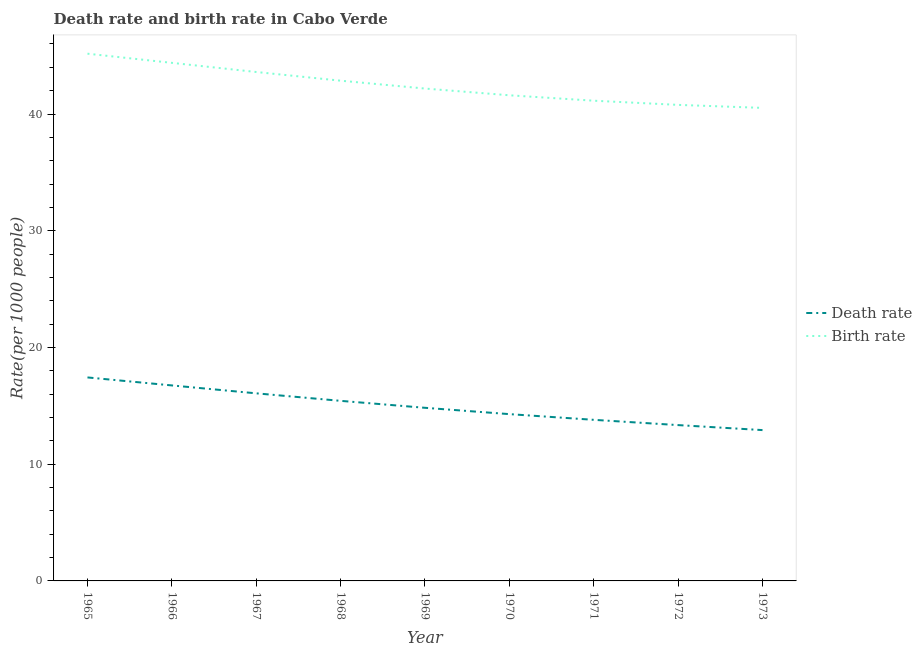How many different coloured lines are there?
Ensure brevity in your answer.  2. Does the line corresponding to birth rate intersect with the line corresponding to death rate?
Offer a very short reply. No. What is the death rate in 1967?
Ensure brevity in your answer.  16.07. Across all years, what is the maximum birth rate?
Your answer should be compact. 45.17. Across all years, what is the minimum birth rate?
Keep it short and to the point. 40.52. In which year was the death rate maximum?
Offer a very short reply. 1965. In which year was the birth rate minimum?
Your answer should be compact. 1973. What is the total birth rate in the graph?
Your answer should be compact. 382.24. What is the difference between the birth rate in 1969 and that in 1971?
Make the answer very short. 1.04. What is the difference between the birth rate in 1967 and the death rate in 1968?
Give a very brief answer. 28.17. What is the average death rate per year?
Your answer should be very brief. 14.99. In the year 1973, what is the difference between the birth rate and death rate?
Your answer should be compact. 27.6. In how many years, is the birth rate greater than 32?
Keep it short and to the point. 9. What is the ratio of the death rate in 1968 to that in 1972?
Make the answer very short. 1.16. Is the birth rate in 1971 less than that in 1972?
Give a very brief answer. No. What is the difference between the highest and the second highest death rate?
Keep it short and to the point. 0.68. What is the difference between the highest and the lowest birth rate?
Your answer should be compact. 4.64. In how many years, is the birth rate greater than the average birth rate taken over all years?
Offer a terse response. 4. Does the death rate monotonically increase over the years?
Provide a short and direct response. No. How many lines are there?
Offer a terse response. 2. Does the graph contain grids?
Provide a short and direct response. No. Where does the legend appear in the graph?
Provide a short and direct response. Center right. How many legend labels are there?
Offer a terse response. 2. How are the legend labels stacked?
Provide a short and direct response. Vertical. What is the title of the graph?
Ensure brevity in your answer.  Death rate and birth rate in Cabo Verde. What is the label or title of the Y-axis?
Your answer should be compact. Rate(per 1000 people). What is the Rate(per 1000 people) in Death rate in 1965?
Keep it short and to the point. 17.43. What is the Rate(per 1000 people) of Birth rate in 1965?
Offer a terse response. 45.17. What is the Rate(per 1000 people) in Death rate in 1966?
Keep it short and to the point. 16.75. What is the Rate(per 1000 people) of Birth rate in 1966?
Give a very brief answer. 44.38. What is the Rate(per 1000 people) in Death rate in 1967?
Ensure brevity in your answer.  16.07. What is the Rate(per 1000 people) in Birth rate in 1967?
Your answer should be very brief. 43.6. What is the Rate(per 1000 people) in Death rate in 1968?
Offer a very short reply. 15.43. What is the Rate(per 1000 people) of Birth rate in 1968?
Your answer should be very brief. 42.85. What is the Rate(per 1000 people) of Death rate in 1969?
Ensure brevity in your answer.  14.83. What is the Rate(per 1000 people) of Birth rate in 1969?
Make the answer very short. 42.18. What is the Rate(per 1000 people) of Death rate in 1970?
Your response must be concise. 14.29. What is the Rate(per 1000 people) of Birth rate in 1970?
Provide a short and direct response. 41.6. What is the Rate(per 1000 people) of Death rate in 1971?
Your answer should be compact. 13.8. What is the Rate(per 1000 people) in Birth rate in 1971?
Keep it short and to the point. 41.14. What is the Rate(per 1000 people) in Death rate in 1972?
Give a very brief answer. 13.35. What is the Rate(per 1000 people) in Birth rate in 1972?
Make the answer very short. 40.78. What is the Rate(per 1000 people) in Death rate in 1973?
Provide a succinct answer. 12.92. What is the Rate(per 1000 people) of Birth rate in 1973?
Offer a terse response. 40.52. Across all years, what is the maximum Rate(per 1000 people) in Death rate?
Your response must be concise. 17.43. Across all years, what is the maximum Rate(per 1000 people) of Birth rate?
Give a very brief answer. 45.17. Across all years, what is the minimum Rate(per 1000 people) in Death rate?
Provide a succinct answer. 12.92. Across all years, what is the minimum Rate(per 1000 people) in Birth rate?
Offer a terse response. 40.52. What is the total Rate(per 1000 people) in Death rate in the graph?
Give a very brief answer. 134.87. What is the total Rate(per 1000 people) of Birth rate in the graph?
Your response must be concise. 382.24. What is the difference between the Rate(per 1000 people) of Death rate in 1965 and that in 1966?
Offer a very short reply. 0.69. What is the difference between the Rate(per 1000 people) in Birth rate in 1965 and that in 1966?
Make the answer very short. 0.78. What is the difference between the Rate(per 1000 people) in Death rate in 1965 and that in 1967?
Make the answer very short. 1.36. What is the difference between the Rate(per 1000 people) in Birth rate in 1965 and that in 1967?
Give a very brief answer. 1.57. What is the difference between the Rate(per 1000 people) in Death rate in 1965 and that in 1968?
Your answer should be compact. 2.01. What is the difference between the Rate(per 1000 people) in Birth rate in 1965 and that in 1968?
Make the answer very short. 2.31. What is the difference between the Rate(per 1000 people) in Death rate in 1965 and that in 1969?
Your answer should be compact. 2.6. What is the difference between the Rate(per 1000 people) of Birth rate in 1965 and that in 1969?
Your response must be concise. 2.99. What is the difference between the Rate(per 1000 people) in Death rate in 1965 and that in 1970?
Provide a short and direct response. 3.14. What is the difference between the Rate(per 1000 people) of Birth rate in 1965 and that in 1970?
Ensure brevity in your answer.  3.56. What is the difference between the Rate(per 1000 people) in Death rate in 1965 and that in 1971?
Offer a terse response. 3.63. What is the difference between the Rate(per 1000 people) in Birth rate in 1965 and that in 1971?
Offer a terse response. 4.03. What is the difference between the Rate(per 1000 people) of Death rate in 1965 and that in 1972?
Your response must be concise. 4.08. What is the difference between the Rate(per 1000 people) of Birth rate in 1965 and that in 1972?
Provide a succinct answer. 4.38. What is the difference between the Rate(per 1000 people) in Death rate in 1965 and that in 1973?
Keep it short and to the point. 4.51. What is the difference between the Rate(per 1000 people) of Birth rate in 1965 and that in 1973?
Your response must be concise. 4.64. What is the difference between the Rate(per 1000 people) in Death rate in 1966 and that in 1967?
Keep it short and to the point. 0.68. What is the difference between the Rate(per 1000 people) of Birth rate in 1966 and that in 1967?
Provide a short and direct response. 0.78. What is the difference between the Rate(per 1000 people) in Death rate in 1966 and that in 1968?
Your answer should be compact. 1.32. What is the difference between the Rate(per 1000 people) in Birth rate in 1966 and that in 1968?
Give a very brief answer. 1.53. What is the difference between the Rate(per 1000 people) of Death rate in 1966 and that in 1969?
Give a very brief answer. 1.92. What is the difference between the Rate(per 1000 people) of Birth rate in 1966 and that in 1969?
Ensure brevity in your answer.  2.2. What is the difference between the Rate(per 1000 people) of Death rate in 1966 and that in 1970?
Ensure brevity in your answer.  2.46. What is the difference between the Rate(per 1000 people) in Birth rate in 1966 and that in 1970?
Your answer should be very brief. 2.78. What is the difference between the Rate(per 1000 people) in Death rate in 1966 and that in 1971?
Offer a terse response. 2.95. What is the difference between the Rate(per 1000 people) in Birth rate in 1966 and that in 1971?
Your response must be concise. 3.24. What is the difference between the Rate(per 1000 people) in Death rate in 1966 and that in 1972?
Ensure brevity in your answer.  3.4. What is the difference between the Rate(per 1000 people) in Birth rate in 1966 and that in 1972?
Give a very brief answer. 3.6. What is the difference between the Rate(per 1000 people) in Death rate in 1966 and that in 1973?
Offer a very short reply. 3.83. What is the difference between the Rate(per 1000 people) of Birth rate in 1966 and that in 1973?
Ensure brevity in your answer.  3.86. What is the difference between the Rate(per 1000 people) in Death rate in 1967 and that in 1968?
Offer a terse response. 0.64. What is the difference between the Rate(per 1000 people) in Birth rate in 1967 and that in 1968?
Give a very brief answer. 0.74. What is the difference between the Rate(per 1000 people) in Death rate in 1967 and that in 1969?
Offer a very short reply. 1.24. What is the difference between the Rate(per 1000 people) of Birth rate in 1967 and that in 1969?
Give a very brief answer. 1.42. What is the difference between the Rate(per 1000 people) in Death rate in 1967 and that in 1970?
Your response must be concise. 1.78. What is the difference between the Rate(per 1000 people) in Birth rate in 1967 and that in 1970?
Offer a very short reply. 2. What is the difference between the Rate(per 1000 people) of Death rate in 1967 and that in 1971?
Provide a short and direct response. 2.27. What is the difference between the Rate(per 1000 people) in Birth rate in 1967 and that in 1971?
Ensure brevity in your answer.  2.46. What is the difference between the Rate(per 1000 people) of Death rate in 1967 and that in 1972?
Ensure brevity in your answer.  2.72. What is the difference between the Rate(per 1000 people) in Birth rate in 1967 and that in 1972?
Keep it short and to the point. 2.82. What is the difference between the Rate(per 1000 people) in Death rate in 1967 and that in 1973?
Make the answer very short. 3.15. What is the difference between the Rate(per 1000 people) in Birth rate in 1967 and that in 1973?
Provide a short and direct response. 3.08. What is the difference between the Rate(per 1000 people) of Death rate in 1968 and that in 1969?
Provide a short and direct response. 0.6. What is the difference between the Rate(per 1000 people) of Birth rate in 1968 and that in 1969?
Make the answer very short. 0.67. What is the difference between the Rate(per 1000 people) in Death rate in 1968 and that in 1970?
Your answer should be compact. 1.14. What is the difference between the Rate(per 1000 people) in Birth rate in 1968 and that in 1970?
Provide a succinct answer. 1.25. What is the difference between the Rate(per 1000 people) in Death rate in 1968 and that in 1971?
Provide a succinct answer. 1.63. What is the difference between the Rate(per 1000 people) of Birth rate in 1968 and that in 1971?
Offer a very short reply. 1.72. What is the difference between the Rate(per 1000 people) of Death rate in 1968 and that in 1972?
Provide a short and direct response. 2.08. What is the difference between the Rate(per 1000 people) in Birth rate in 1968 and that in 1972?
Your response must be concise. 2.07. What is the difference between the Rate(per 1000 people) in Death rate in 1968 and that in 1973?
Give a very brief answer. 2.51. What is the difference between the Rate(per 1000 people) of Birth rate in 1968 and that in 1973?
Your answer should be very brief. 2.33. What is the difference between the Rate(per 1000 people) of Death rate in 1969 and that in 1970?
Give a very brief answer. 0.54. What is the difference between the Rate(per 1000 people) of Birth rate in 1969 and that in 1970?
Provide a short and direct response. 0.58. What is the difference between the Rate(per 1000 people) in Birth rate in 1969 and that in 1971?
Ensure brevity in your answer.  1.04. What is the difference between the Rate(per 1000 people) in Death rate in 1969 and that in 1972?
Your answer should be very brief. 1.48. What is the difference between the Rate(per 1000 people) in Birth rate in 1969 and that in 1972?
Give a very brief answer. 1.4. What is the difference between the Rate(per 1000 people) in Death rate in 1969 and that in 1973?
Provide a short and direct response. 1.91. What is the difference between the Rate(per 1000 people) of Birth rate in 1969 and that in 1973?
Provide a short and direct response. 1.66. What is the difference between the Rate(per 1000 people) in Death rate in 1970 and that in 1971?
Make the answer very short. 0.49. What is the difference between the Rate(per 1000 people) of Birth rate in 1970 and that in 1971?
Provide a succinct answer. 0.46. What is the difference between the Rate(per 1000 people) in Birth rate in 1970 and that in 1972?
Ensure brevity in your answer.  0.82. What is the difference between the Rate(per 1000 people) of Death rate in 1970 and that in 1973?
Offer a very short reply. 1.37. What is the difference between the Rate(per 1000 people) of Death rate in 1971 and that in 1972?
Give a very brief answer. 0.45. What is the difference between the Rate(per 1000 people) in Birth rate in 1971 and that in 1972?
Keep it short and to the point. 0.36. What is the difference between the Rate(per 1000 people) of Birth rate in 1971 and that in 1973?
Your response must be concise. 0.62. What is the difference between the Rate(per 1000 people) of Death rate in 1972 and that in 1973?
Offer a very short reply. 0.43. What is the difference between the Rate(per 1000 people) of Birth rate in 1972 and that in 1973?
Your answer should be compact. 0.26. What is the difference between the Rate(per 1000 people) of Death rate in 1965 and the Rate(per 1000 people) of Birth rate in 1966?
Offer a terse response. -26.95. What is the difference between the Rate(per 1000 people) of Death rate in 1965 and the Rate(per 1000 people) of Birth rate in 1967?
Offer a very short reply. -26.17. What is the difference between the Rate(per 1000 people) in Death rate in 1965 and the Rate(per 1000 people) in Birth rate in 1968?
Keep it short and to the point. -25.42. What is the difference between the Rate(per 1000 people) of Death rate in 1965 and the Rate(per 1000 people) of Birth rate in 1969?
Give a very brief answer. -24.75. What is the difference between the Rate(per 1000 people) in Death rate in 1965 and the Rate(per 1000 people) in Birth rate in 1970?
Offer a very short reply. -24.17. What is the difference between the Rate(per 1000 people) of Death rate in 1965 and the Rate(per 1000 people) of Birth rate in 1971?
Make the answer very short. -23.71. What is the difference between the Rate(per 1000 people) of Death rate in 1965 and the Rate(per 1000 people) of Birth rate in 1972?
Offer a terse response. -23.35. What is the difference between the Rate(per 1000 people) in Death rate in 1965 and the Rate(per 1000 people) in Birth rate in 1973?
Your answer should be very brief. -23.09. What is the difference between the Rate(per 1000 people) in Death rate in 1966 and the Rate(per 1000 people) in Birth rate in 1967?
Keep it short and to the point. -26.85. What is the difference between the Rate(per 1000 people) of Death rate in 1966 and the Rate(per 1000 people) of Birth rate in 1968?
Ensure brevity in your answer.  -26.11. What is the difference between the Rate(per 1000 people) in Death rate in 1966 and the Rate(per 1000 people) in Birth rate in 1969?
Ensure brevity in your answer.  -25.43. What is the difference between the Rate(per 1000 people) in Death rate in 1966 and the Rate(per 1000 people) in Birth rate in 1970?
Make the answer very short. -24.86. What is the difference between the Rate(per 1000 people) of Death rate in 1966 and the Rate(per 1000 people) of Birth rate in 1971?
Keep it short and to the point. -24.39. What is the difference between the Rate(per 1000 people) in Death rate in 1966 and the Rate(per 1000 people) in Birth rate in 1972?
Your answer should be very brief. -24.03. What is the difference between the Rate(per 1000 people) in Death rate in 1966 and the Rate(per 1000 people) in Birth rate in 1973?
Provide a short and direct response. -23.78. What is the difference between the Rate(per 1000 people) in Death rate in 1967 and the Rate(per 1000 people) in Birth rate in 1968?
Offer a terse response. -26.78. What is the difference between the Rate(per 1000 people) of Death rate in 1967 and the Rate(per 1000 people) of Birth rate in 1969?
Your answer should be compact. -26.11. What is the difference between the Rate(per 1000 people) in Death rate in 1967 and the Rate(per 1000 people) in Birth rate in 1970?
Give a very brief answer. -25.53. What is the difference between the Rate(per 1000 people) of Death rate in 1967 and the Rate(per 1000 people) of Birth rate in 1971?
Offer a very short reply. -25.07. What is the difference between the Rate(per 1000 people) in Death rate in 1967 and the Rate(per 1000 people) in Birth rate in 1972?
Give a very brief answer. -24.71. What is the difference between the Rate(per 1000 people) in Death rate in 1967 and the Rate(per 1000 people) in Birth rate in 1973?
Your response must be concise. -24.45. What is the difference between the Rate(per 1000 people) of Death rate in 1968 and the Rate(per 1000 people) of Birth rate in 1969?
Keep it short and to the point. -26.75. What is the difference between the Rate(per 1000 people) of Death rate in 1968 and the Rate(per 1000 people) of Birth rate in 1970?
Your answer should be very brief. -26.18. What is the difference between the Rate(per 1000 people) of Death rate in 1968 and the Rate(per 1000 people) of Birth rate in 1971?
Keep it short and to the point. -25.71. What is the difference between the Rate(per 1000 people) in Death rate in 1968 and the Rate(per 1000 people) in Birth rate in 1972?
Your response must be concise. -25.36. What is the difference between the Rate(per 1000 people) in Death rate in 1968 and the Rate(per 1000 people) in Birth rate in 1973?
Give a very brief answer. -25.1. What is the difference between the Rate(per 1000 people) of Death rate in 1969 and the Rate(per 1000 people) of Birth rate in 1970?
Keep it short and to the point. -26.77. What is the difference between the Rate(per 1000 people) in Death rate in 1969 and the Rate(per 1000 people) in Birth rate in 1971?
Provide a succinct answer. -26.31. What is the difference between the Rate(per 1000 people) of Death rate in 1969 and the Rate(per 1000 people) of Birth rate in 1972?
Keep it short and to the point. -25.95. What is the difference between the Rate(per 1000 people) of Death rate in 1969 and the Rate(per 1000 people) of Birth rate in 1973?
Your response must be concise. -25.69. What is the difference between the Rate(per 1000 people) in Death rate in 1970 and the Rate(per 1000 people) in Birth rate in 1971?
Make the answer very short. -26.85. What is the difference between the Rate(per 1000 people) in Death rate in 1970 and the Rate(per 1000 people) in Birth rate in 1972?
Your response must be concise. -26.49. What is the difference between the Rate(per 1000 people) in Death rate in 1970 and the Rate(per 1000 people) in Birth rate in 1973?
Give a very brief answer. -26.23. What is the difference between the Rate(per 1000 people) in Death rate in 1971 and the Rate(per 1000 people) in Birth rate in 1972?
Make the answer very short. -26.98. What is the difference between the Rate(per 1000 people) of Death rate in 1971 and the Rate(per 1000 people) of Birth rate in 1973?
Offer a very short reply. -26.72. What is the difference between the Rate(per 1000 people) in Death rate in 1972 and the Rate(per 1000 people) in Birth rate in 1973?
Offer a very short reply. -27.18. What is the average Rate(per 1000 people) of Death rate per year?
Offer a terse response. 14.99. What is the average Rate(per 1000 people) of Birth rate per year?
Your answer should be compact. 42.47. In the year 1965, what is the difference between the Rate(per 1000 people) in Death rate and Rate(per 1000 people) in Birth rate?
Provide a succinct answer. -27.73. In the year 1966, what is the difference between the Rate(per 1000 people) in Death rate and Rate(per 1000 people) in Birth rate?
Your response must be concise. -27.64. In the year 1967, what is the difference between the Rate(per 1000 people) of Death rate and Rate(per 1000 people) of Birth rate?
Your answer should be compact. -27.53. In the year 1968, what is the difference between the Rate(per 1000 people) in Death rate and Rate(per 1000 people) in Birth rate?
Ensure brevity in your answer.  -27.43. In the year 1969, what is the difference between the Rate(per 1000 people) of Death rate and Rate(per 1000 people) of Birth rate?
Make the answer very short. -27.35. In the year 1970, what is the difference between the Rate(per 1000 people) of Death rate and Rate(per 1000 people) of Birth rate?
Provide a short and direct response. -27.32. In the year 1971, what is the difference between the Rate(per 1000 people) of Death rate and Rate(per 1000 people) of Birth rate?
Offer a very short reply. -27.34. In the year 1972, what is the difference between the Rate(per 1000 people) of Death rate and Rate(per 1000 people) of Birth rate?
Ensure brevity in your answer.  -27.43. In the year 1973, what is the difference between the Rate(per 1000 people) in Death rate and Rate(per 1000 people) in Birth rate?
Offer a very short reply. -27.6. What is the ratio of the Rate(per 1000 people) of Death rate in 1965 to that in 1966?
Make the answer very short. 1.04. What is the ratio of the Rate(per 1000 people) in Birth rate in 1965 to that in 1966?
Provide a succinct answer. 1.02. What is the ratio of the Rate(per 1000 people) in Death rate in 1965 to that in 1967?
Provide a succinct answer. 1.08. What is the ratio of the Rate(per 1000 people) of Birth rate in 1965 to that in 1967?
Ensure brevity in your answer.  1.04. What is the ratio of the Rate(per 1000 people) in Death rate in 1965 to that in 1968?
Keep it short and to the point. 1.13. What is the ratio of the Rate(per 1000 people) in Birth rate in 1965 to that in 1968?
Offer a terse response. 1.05. What is the ratio of the Rate(per 1000 people) of Death rate in 1965 to that in 1969?
Provide a short and direct response. 1.18. What is the ratio of the Rate(per 1000 people) in Birth rate in 1965 to that in 1969?
Your answer should be very brief. 1.07. What is the ratio of the Rate(per 1000 people) in Death rate in 1965 to that in 1970?
Provide a succinct answer. 1.22. What is the ratio of the Rate(per 1000 people) in Birth rate in 1965 to that in 1970?
Your answer should be very brief. 1.09. What is the ratio of the Rate(per 1000 people) of Death rate in 1965 to that in 1971?
Your response must be concise. 1.26. What is the ratio of the Rate(per 1000 people) in Birth rate in 1965 to that in 1971?
Offer a very short reply. 1.1. What is the ratio of the Rate(per 1000 people) of Death rate in 1965 to that in 1972?
Your response must be concise. 1.31. What is the ratio of the Rate(per 1000 people) of Birth rate in 1965 to that in 1972?
Provide a short and direct response. 1.11. What is the ratio of the Rate(per 1000 people) in Death rate in 1965 to that in 1973?
Offer a terse response. 1.35. What is the ratio of the Rate(per 1000 people) in Birth rate in 1965 to that in 1973?
Offer a terse response. 1.11. What is the ratio of the Rate(per 1000 people) in Death rate in 1966 to that in 1967?
Offer a terse response. 1.04. What is the ratio of the Rate(per 1000 people) in Birth rate in 1966 to that in 1967?
Ensure brevity in your answer.  1.02. What is the ratio of the Rate(per 1000 people) of Death rate in 1966 to that in 1968?
Provide a succinct answer. 1.09. What is the ratio of the Rate(per 1000 people) in Birth rate in 1966 to that in 1968?
Make the answer very short. 1.04. What is the ratio of the Rate(per 1000 people) of Death rate in 1966 to that in 1969?
Give a very brief answer. 1.13. What is the ratio of the Rate(per 1000 people) in Birth rate in 1966 to that in 1969?
Keep it short and to the point. 1.05. What is the ratio of the Rate(per 1000 people) in Death rate in 1966 to that in 1970?
Offer a very short reply. 1.17. What is the ratio of the Rate(per 1000 people) in Birth rate in 1966 to that in 1970?
Provide a succinct answer. 1.07. What is the ratio of the Rate(per 1000 people) of Death rate in 1966 to that in 1971?
Offer a very short reply. 1.21. What is the ratio of the Rate(per 1000 people) of Birth rate in 1966 to that in 1971?
Your answer should be very brief. 1.08. What is the ratio of the Rate(per 1000 people) of Death rate in 1966 to that in 1972?
Your answer should be very brief. 1.25. What is the ratio of the Rate(per 1000 people) of Birth rate in 1966 to that in 1972?
Your answer should be very brief. 1.09. What is the ratio of the Rate(per 1000 people) in Death rate in 1966 to that in 1973?
Ensure brevity in your answer.  1.3. What is the ratio of the Rate(per 1000 people) in Birth rate in 1966 to that in 1973?
Keep it short and to the point. 1.1. What is the ratio of the Rate(per 1000 people) of Death rate in 1967 to that in 1968?
Your answer should be very brief. 1.04. What is the ratio of the Rate(per 1000 people) in Birth rate in 1967 to that in 1968?
Provide a short and direct response. 1.02. What is the ratio of the Rate(per 1000 people) in Death rate in 1967 to that in 1969?
Your answer should be compact. 1.08. What is the ratio of the Rate(per 1000 people) in Birth rate in 1967 to that in 1969?
Offer a very short reply. 1.03. What is the ratio of the Rate(per 1000 people) in Death rate in 1967 to that in 1970?
Give a very brief answer. 1.12. What is the ratio of the Rate(per 1000 people) of Birth rate in 1967 to that in 1970?
Your answer should be compact. 1.05. What is the ratio of the Rate(per 1000 people) of Death rate in 1967 to that in 1971?
Give a very brief answer. 1.16. What is the ratio of the Rate(per 1000 people) of Birth rate in 1967 to that in 1971?
Offer a very short reply. 1.06. What is the ratio of the Rate(per 1000 people) of Death rate in 1967 to that in 1972?
Provide a succinct answer. 1.2. What is the ratio of the Rate(per 1000 people) of Birth rate in 1967 to that in 1972?
Provide a short and direct response. 1.07. What is the ratio of the Rate(per 1000 people) in Death rate in 1967 to that in 1973?
Provide a short and direct response. 1.24. What is the ratio of the Rate(per 1000 people) of Birth rate in 1967 to that in 1973?
Offer a terse response. 1.08. What is the ratio of the Rate(per 1000 people) in Death rate in 1968 to that in 1969?
Offer a terse response. 1.04. What is the ratio of the Rate(per 1000 people) of Birth rate in 1968 to that in 1969?
Provide a short and direct response. 1.02. What is the ratio of the Rate(per 1000 people) of Death rate in 1968 to that in 1970?
Your answer should be very brief. 1.08. What is the ratio of the Rate(per 1000 people) of Birth rate in 1968 to that in 1970?
Make the answer very short. 1.03. What is the ratio of the Rate(per 1000 people) of Death rate in 1968 to that in 1971?
Make the answer very short. 1.12. What is the ratio of the Rate(per 1000 people) in Birth rate in 1968 to that in 1971?
Offer a terse response. 1.04. What is the ratio of the Rate(per 1000 people) in Death rate in 1968 to that in 1972?
Give a very brief answer. 1.16. What is the ratio of the Rate(per 1000 people) in Birth rate in 1968 to that in 1972?
Ensure brevity in your answer.  1.05. What is the ratio of the Rate(per 1000 people) in Death rate in 1968 to that in 1973?
Give a very brief answer. 1.19. What is the ratio of the Rate(per 1000 people) in Birth rate in 1968 to that in 1973?
Ensure brevity in your answer.  1.06. What is the ratio of the Rate(per 1000 people) of Death rate in 1969 to that in 1970?
Your response must be concise. 1.04. What is the ratio of the Rate(per 1000 people) in Birth rate in 1969 to that in 1970?
Your answer should be very brief. 1.01. What is the ratio of the Rate(per 1000 people) in Death rate in 1969 to that in 1971?
Provide a succinct answer. 1.07. What is the ratio of the Rate(per 1000 people) in Birth rate in 1969 to that in 1971?
Your response must be concise. 1.03. What is the ratio of the Rate(per 1000 people) of Death rate in 1969 to that in 1972?
Your answer should be compact. 1.11. What is the ratio of the Rate(per 1000 people) in Birth rate in 1969 to that in 1972?
Provide a succinct answer. 1.03. What is the ratio of the Rate(per 1000 people) in Death rate in 1969 to that in 1973?
Your answer should be compact. 1.15. What is the ratio of the Rate(per 1000 people) in Birth rate in 1969 to that in 1973?
Ensure brevity in your answer.  1.04. What is the ratio of the Rate(per 1000 people) in Death rate in 1970 to that in 1971?
Give a very brief answer. 1.04. What is the ratio of the Rate(per 1000 people) of Birth rate in 1970 to that in 1971?
Give a very brief answer. 1.01. What is the ratio of the Rate(per 1000 people) of Death rate in 1970 to that in 1972?
Ensure brevity in your answer.  1.07. What is the ratio of the Rate(per 1000 people) in Birth rate in 1970 to that in 1972?
Offer a terse response. 1.02. What is the ratio of the Rate(per 1000 people) of Death rate in 1970 to that in 1973?
Provide a succinct answer. 1.11. What is the ratio of the Rate(per 1000 people) in Birth rate in 1970 to that in 1973?
Ensure brevity in your answer.  1.03. What is the ratio of the Rate(per 1000 people) of Death rate in 1971 to that in 1972?
Offer a terse response. 1.03. What is the ratio of the Rate(per 1000 people) in Birth rate in 1971 to that in 1972?
Offer a terse response. 1.01. What is the ratio of the Rate(per 1000 people) in Death rate in 1971 to that in 1973?
Offer a terse response. 1.07. What is the ratio of the Rate(per 1000 people) of Birth rate in 1971 to that in 1973?
Ensure brevity in your answer.  1.02. What is the ratio of the Rate(per 1000 people) of Death rate in 1972 to that in 1973?
Ensure brevity in your answer.  1.03. What is the ratio of the Rate(per 1000 people) of Birth rate in 1972 to that in 1973?
Give a very brief answer. 1.01. What is the difference between the highest and the second highest Rate(per 1000 people) in Death rate?
Give a very brief answer. 0.69. What is the difference between the highest and the second highest Rate(per 1000 people) of Birth rate?
Provide a succinct answer. 0.78. What is the difference between the highest and the lowest Rate(per 1000 people) in Death rate?
Your answer should be compact. 4.51. What is the difference between the highest and the lowest Rate(per 1000 people) of Birth rate?
Your answer should be very brief. 4.64. 